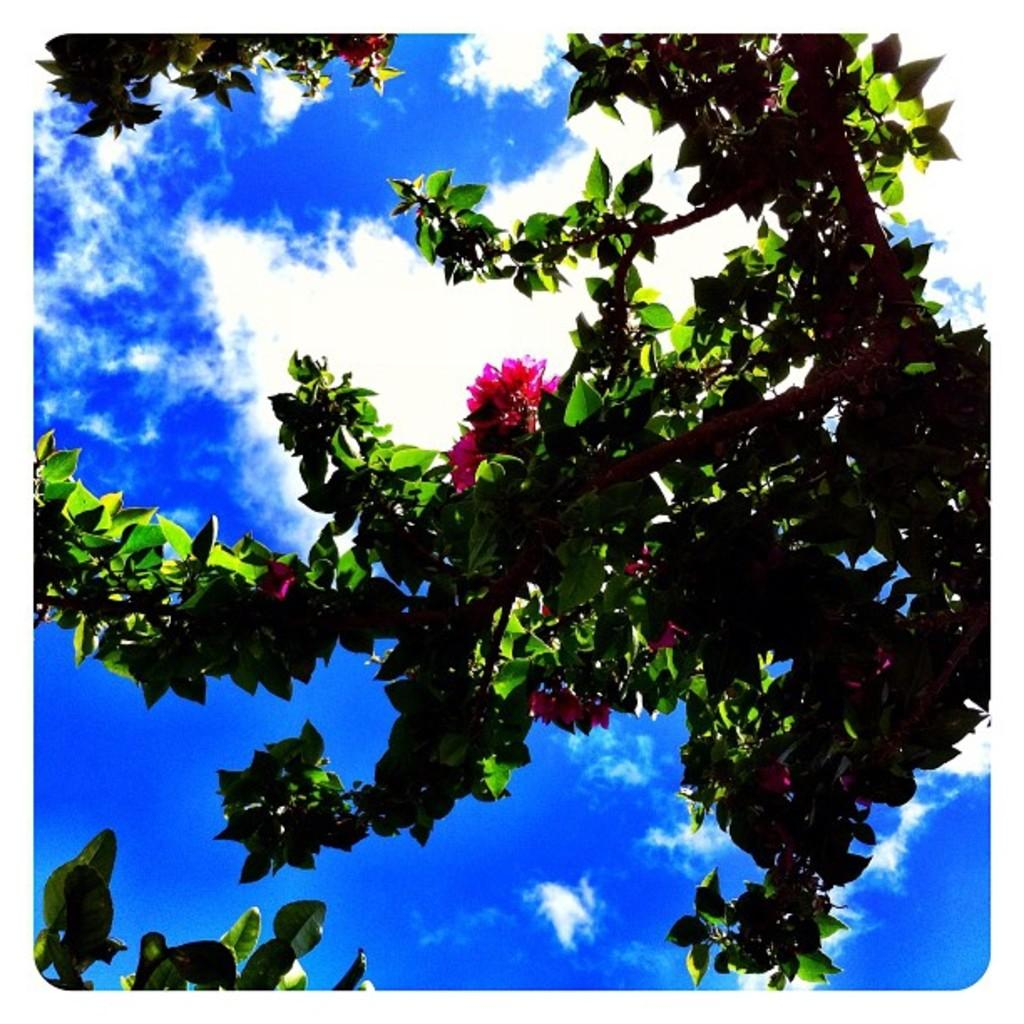What type of vegetation is present in the image? There are branches with flowers and leaves in the image. What can be seen in the sky in the background of the image? There are clouds in the sky in the background of the image. What question is being asked in the image? There is no question being asked in the image; it features branches with flowers and leaves, and clouds in the sky. 